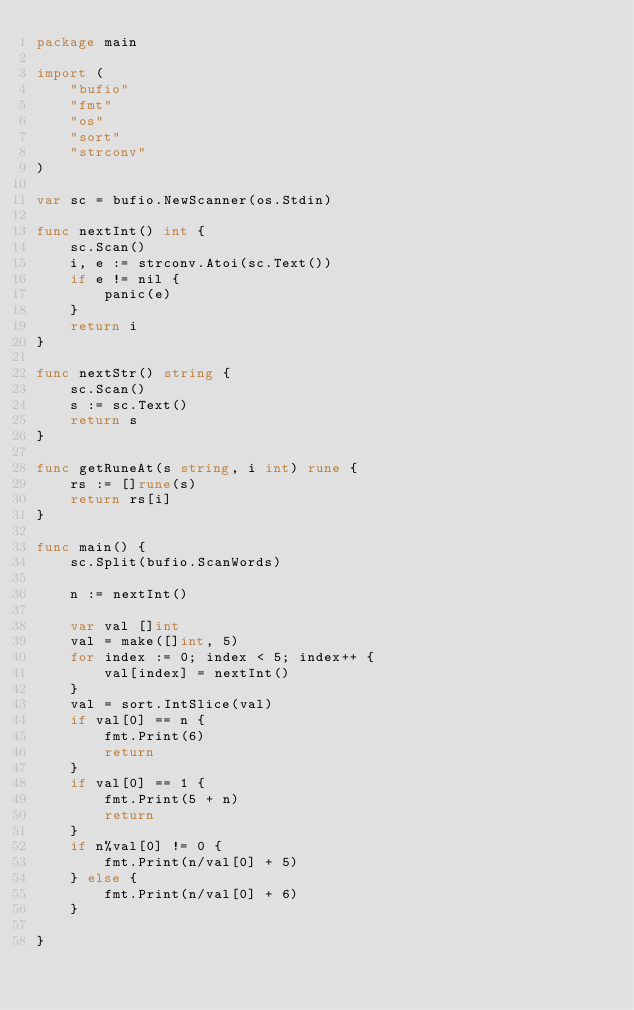Convert code to text. <code><loc_0><loc_0><loc_500><loc_500><_Go_>package main

import (
	"bufio"
	"fmt"
	"os"
	"sort"
	"strconv"
)

var sc = bufio.NewScanner(os.Stdin)

func nextInt() int {
	sc.Scan()
	i, e := strconv.Atoi(sc.Text())
	if e != nil {
		panic(e)
	}
	return i
}

func nextStr() string {
	sc.Scan()
	s := sc.Text()
	return s
}

func getRuneAt(s string, i int) rune {
	rs := []rune(s)
	return rs[i]
}

func main() {
	sc.Split(bufio.ScanWords)

	n := nextInt()

	var val []int
	val = make([]int, 5)
	for index := 0; index < 5; index++ {
		val[index] = nextInt()
	}
	val = sort.IntSlice(val)
	if val[0] == n {
		fmt.Print(6)
		return
	}
	if val[0] == 1 {
		fmt.Print(5 + n)
		return
	}
	if n%val[0] != 0 {
		fmt.Print(n/val[0] + 5)
	} else {
		fmt.Print(n/val[0] + 6)
	}

}</code> 